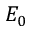<formula> <loc_0><loc_0><loc_500><loc_500>E _ { 0 }</formula> 